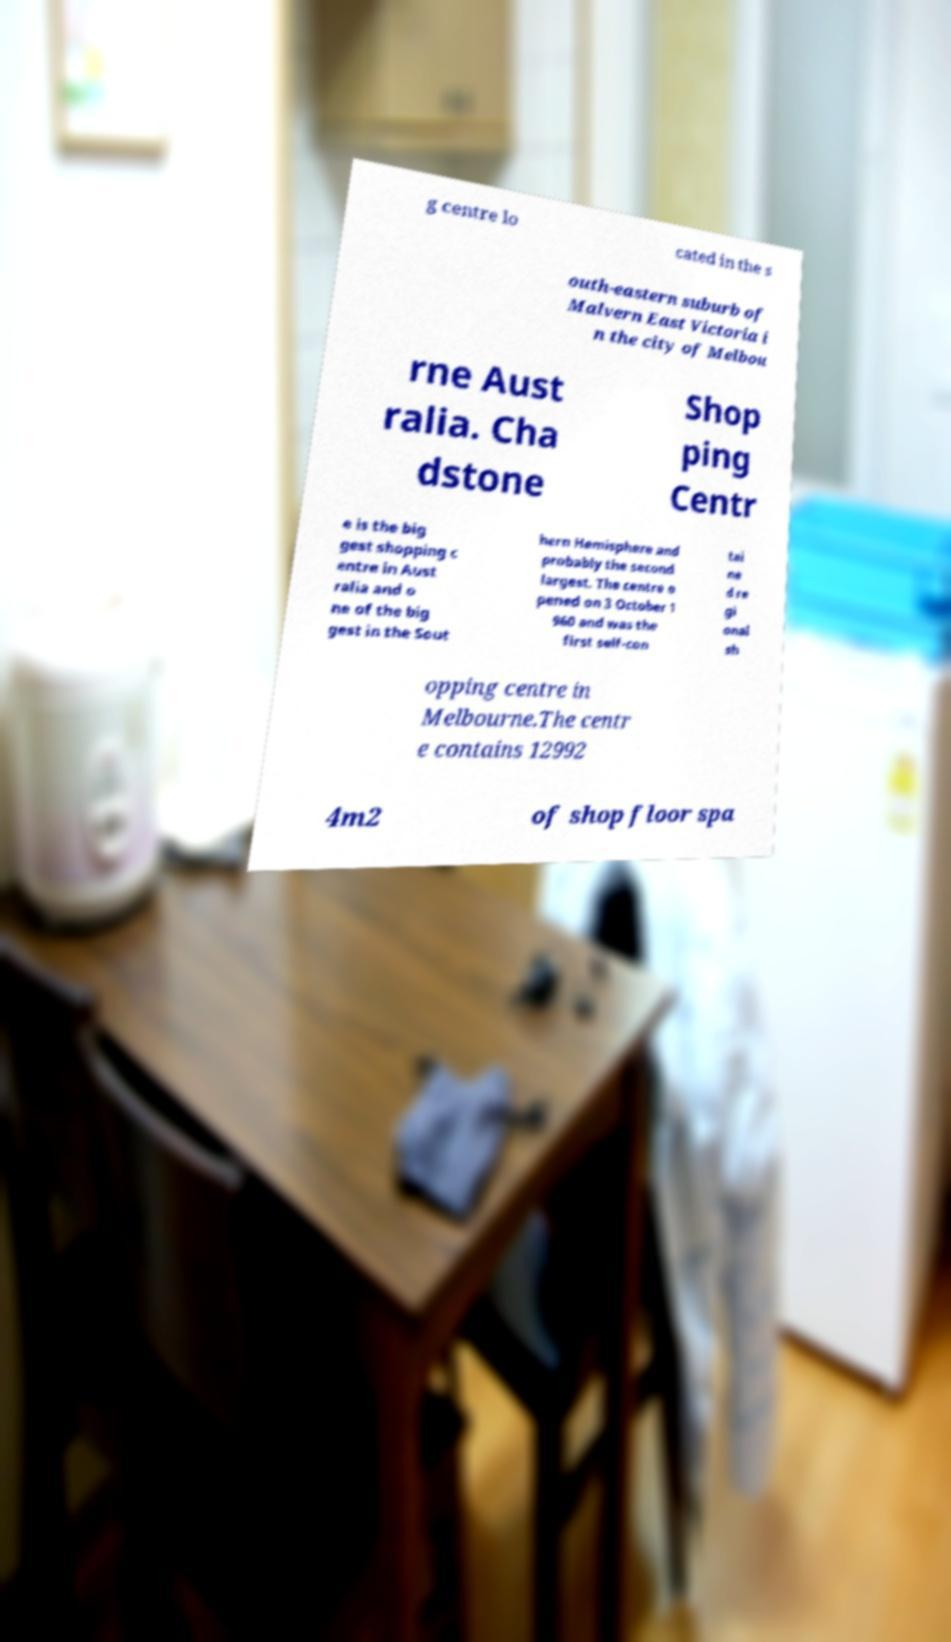For documentation purposes, I need the text within this image transcribed. Could you provide that? g centre lo cated in the s outh-eastern suburb of Malvern East Victoria i n the city of Melbou rne Aust ralia. Cha dstone Shop ping Centr e is the big gest shopping c entre in Aust ralia and o ne of the big gest in the Sout hern Hemisphere and probably the second largest. The centre o pened on 3 October 1 960 and was the first self-con tai ne d re gi onal sh opping centre in Melbourne.The centr e contains 12992 4m2 of shop floor spa 